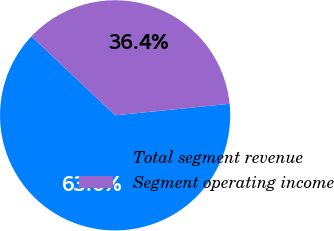Convert chart. <chart><loc_0><loc_0><loc_500><loc_500><pie_chart><fcel>Total segment revenue<fcel>Segment operating income<nl><fcel>63.64%<fcel>36.36%<nl></chart> 